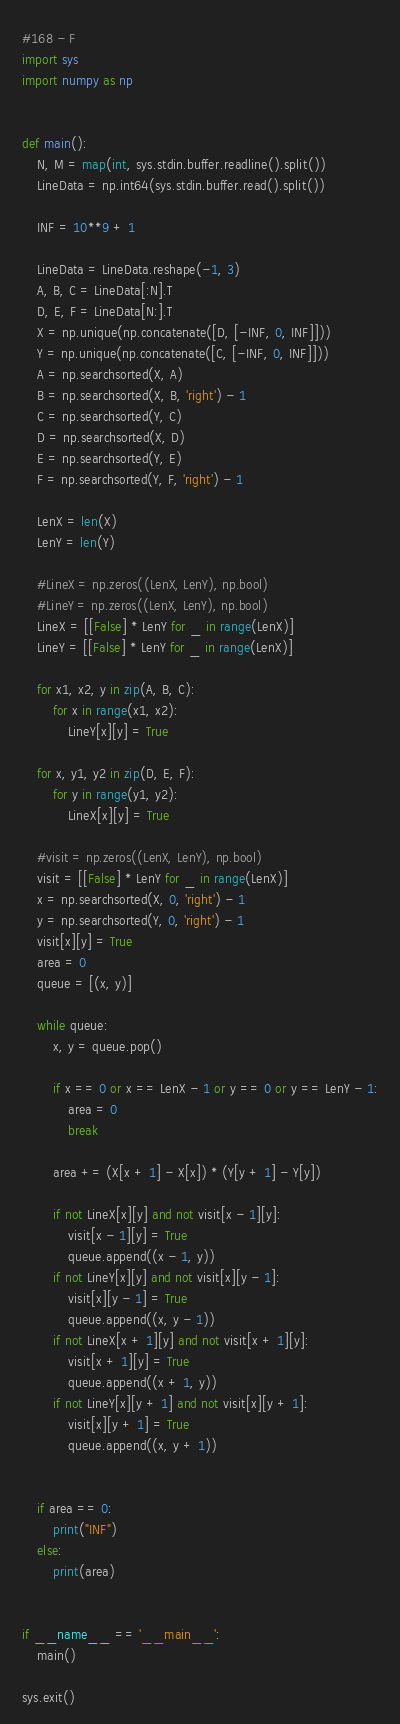<code> <loc_0><loc_0><loc_500><loc_500><_Python_>#168 - F
import sys
import numpy as np


def main():
    N, M = map(int, sys.stdin.buffer.readline().split())
    LineData = np.int64(sys.stdin.buffer.read().split())

    INF = 10**9 + 1

    LineData = LineData.reshape(-1, 3)
    A, B, C = LineData[:N].T
    D, E, F = LineData[N:].T
    X = np.unique(np.concatenate([D, [-INF, 0, INF]]))
    Y = np.unique(np.concatenate([C, [-INF, 0, INF]]))
    A = np.searchsorted(X, A)
    B = np.searchsorted(X, B, 'right') - 1
    C = np.searchsorted(Y, C)
    D = np.searchsorted(X, D)
    E = np.searchsorted(Y, E)
    F = np.searchsorted(Y, F, 'right') - 1

    LenX = len(X)
    LenY = len(Y)

    #LineX = np.zeros((LenX, LenY), np.bool)
    #LineY = np.zeros((LenX, LenY), np.bool)
    LineX = [[False] * LenY for _ in range(LenX)]
    LineY = [[False] * LenY for _ in range(LenX)]

    for x1, x2, y in zip(A, B, C):
        for x in range(x1, x2):
            LineY[x][y] = True

    for x, y1, y2 in zip(D, E, F):
        for y in range(y1, y2):
            LineX[x][y] = True
    
    #visit = np.zeros((LenX, LenY), np.bool)
    visit = [[False] * LenY for _ in range(LenX)]
    x = np.searchsorted(X, 0, 'right') - 1
    y = np.searchsorted(Y, 0, 'right') - 1
    visit[x][y] = True
    area = 0
    queue = [(x, y)]

    while queue:
        x, y = queue.pop()

        if x == 0 or x == LenX - 1 or y == 0 or y == LenY - 1:
            area = 0
            break
        
        area += (X[x + 1] - X[x]) * (Y[y + 1] - Y[y])

        if not LineX[x][y] and not visit[x - 1][y]:
            visit[x - 1][y] = True
            queue.append((x - 1, y))
        if not LineY[x][y] and not visit[x][y - 1]:
            visit[x][y - 1] = True
            queue.append((x, y - 1))
        if not LineX[x + 1][y] and not visit[x + 1][y]:
            visit[x + 1][y] = True
            queue.append((x + 1, y))
        if not LineY[x][y + 1] and not visit[x][y + 1]:
            visit[x][y + 1] = True
            queue.append((x, y + 1))


    if area == 0:
        print("INF")
    else:
        print(area)


if __name__ == '__main__':
	main()

sys.exit()
</code> 